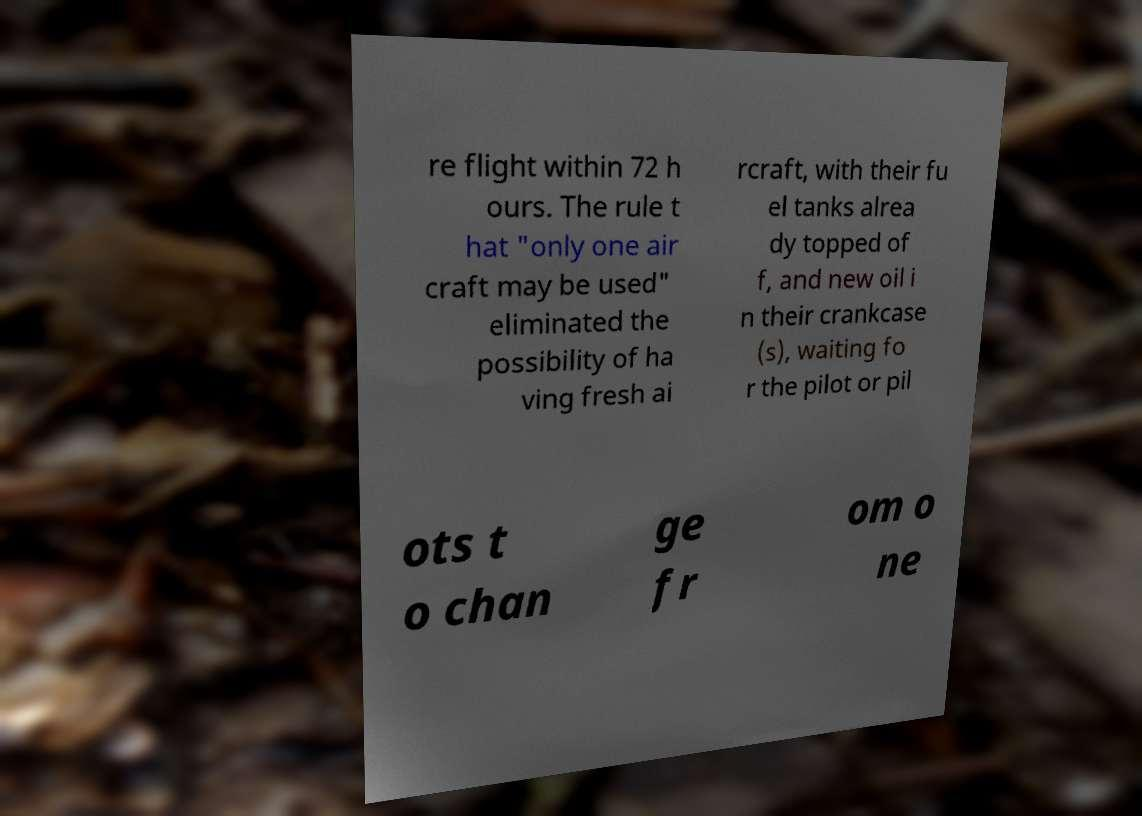I need the written content from this picture converted into text. Can you do that? re flight within 72 h ours. The rule t hat "only one air craft may be used" eliminated the possibility of ha ving fresh ai rcraft, with their fu el tanks alrea dy topped of f, and new oil i n their crankcase (s), waiting fo r the pilot or pil ots t o chan ge fr om o ne 